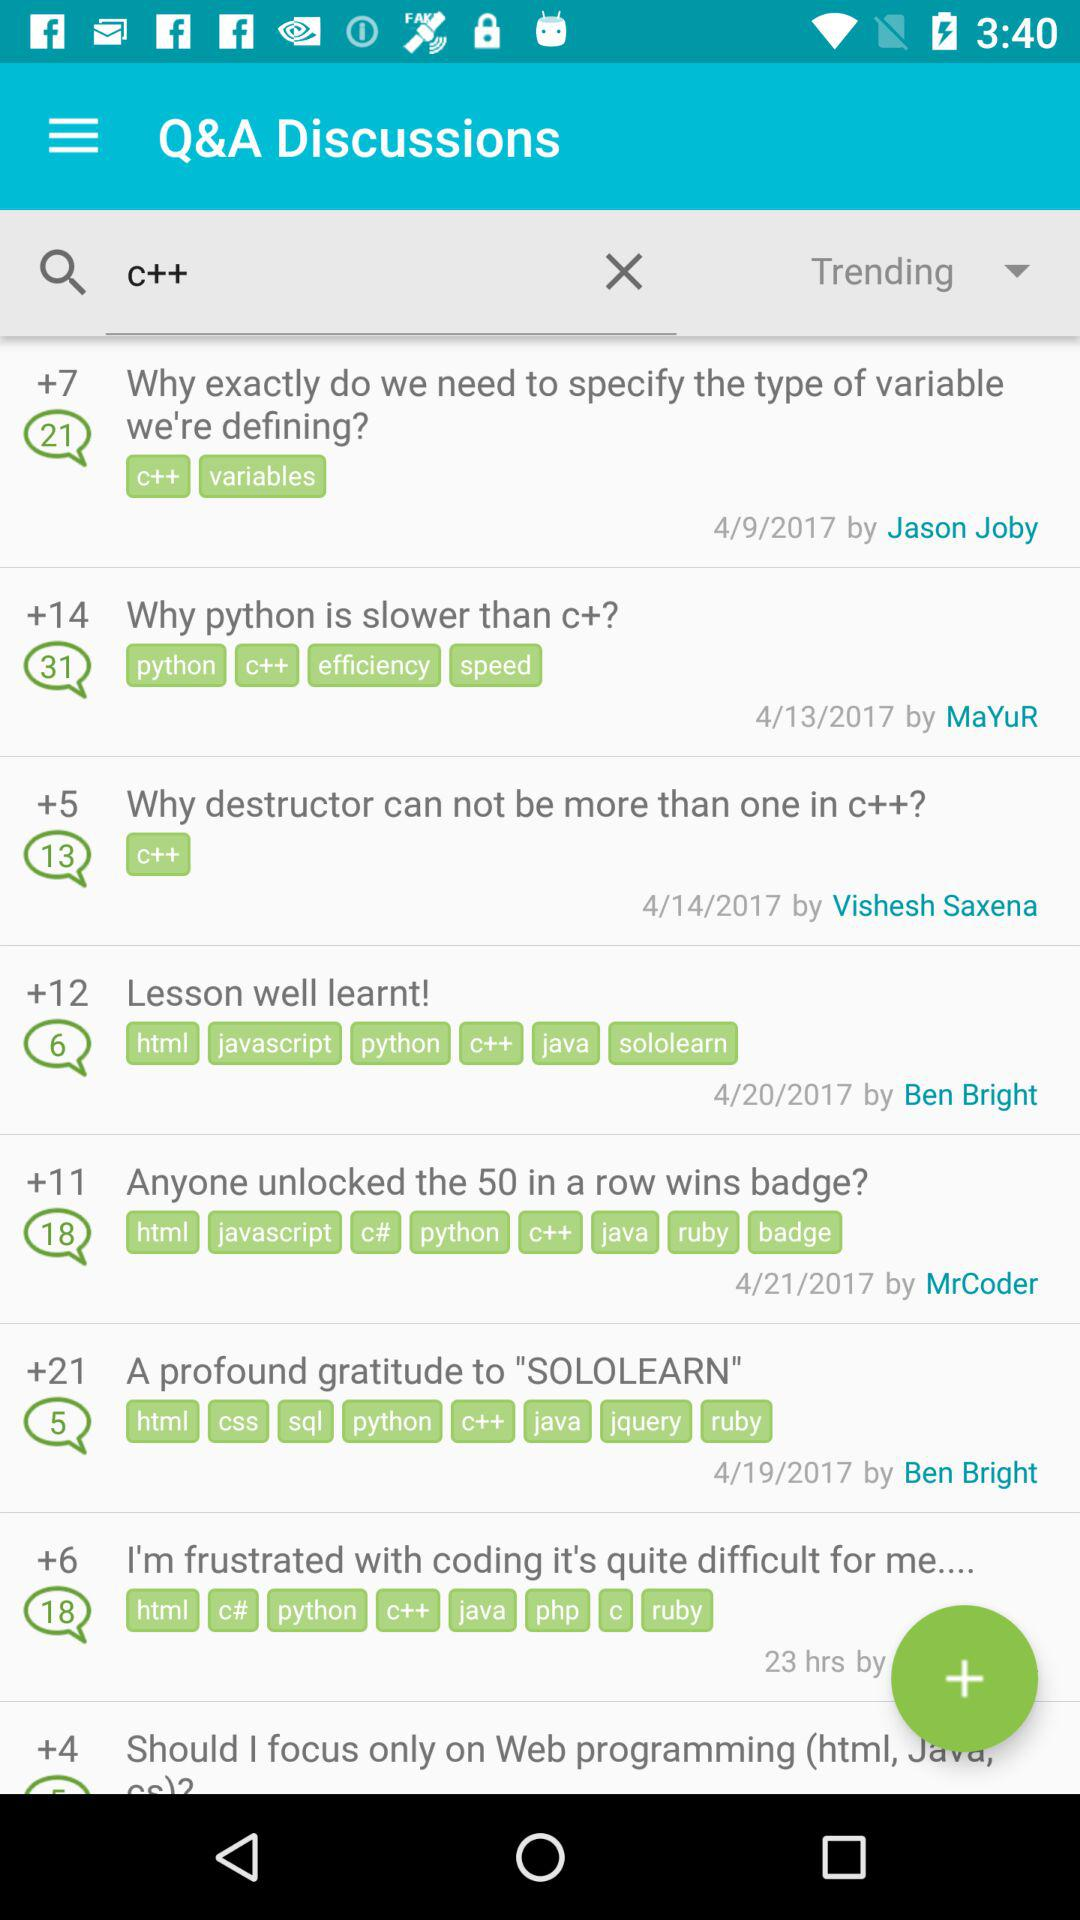What is the posted date of the question "Why python is slower than c+"? The posted date is April 13, 2017. 